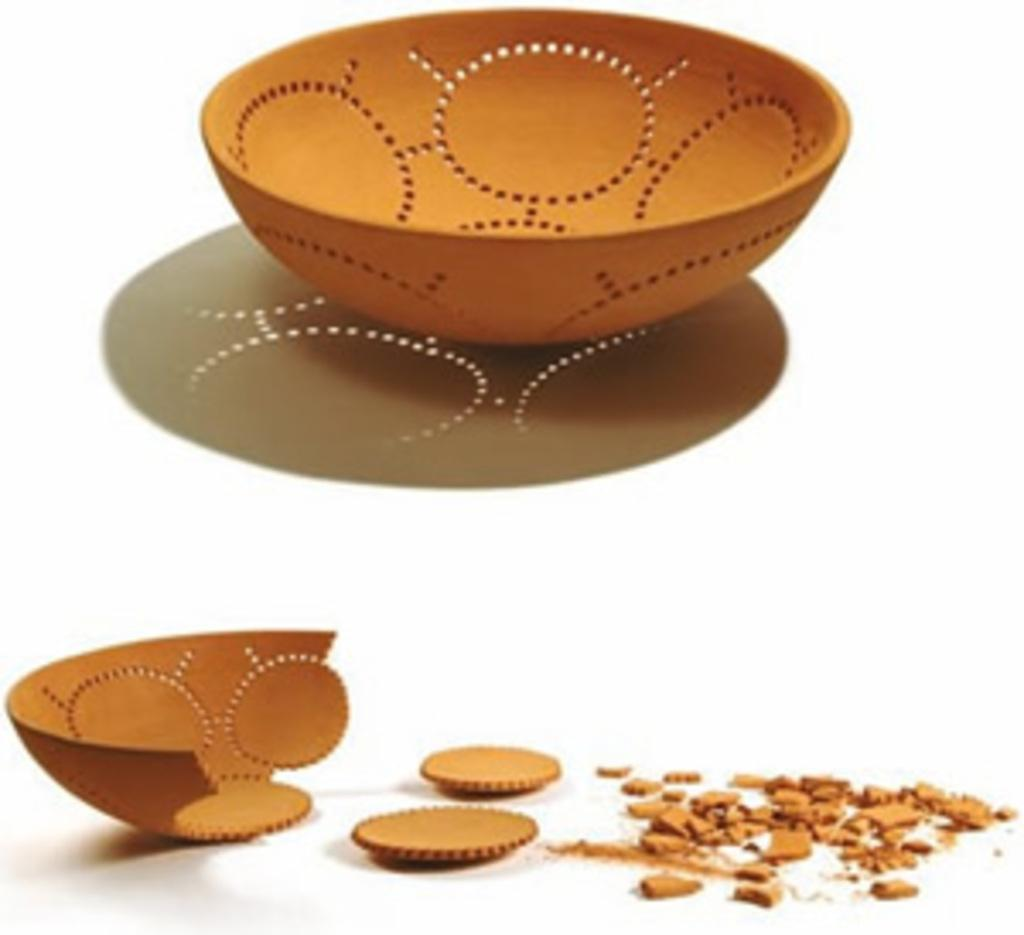What is present in the image that is related to food or drink? There is a bowl in the image. Can you describe the condition of the second bowl in the image? The second bowl is broken into pieces. What color is the background of the image? The background of the image is white. How many kittens are playing with the broken bowl in the image? There are no kittens present in the image, and the broken bowl is not associated with any playful activity. 